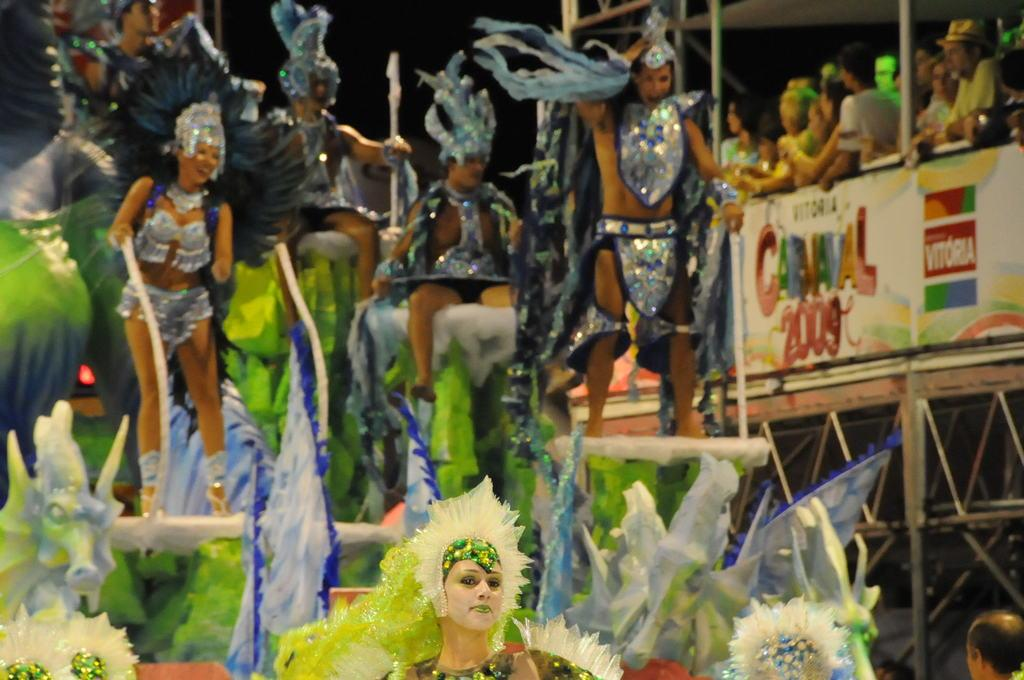What are the people in the image wearing? The people in the image are wearing costumes. What are some of the people holding in the image? Some people are holding objects in the image. What can be seen supporting the objects or people in the image? There are poles in the image. What is visible beneath the people and objects in the image? The floor is visible in the image. What is written or displayed on the poster in the image? There is a poster with text in the image. What is the condition of the sky in the image? The sky is dark in the image. What type of train can be seen passing by in the image? There is no train present in the image. 